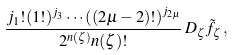<formula> <loc_0><loc_0><loc_500><loc_500>\frac { j _ { 1 } ! ( 1 ! ) ^ { j _ { 3 } } \cdots \left ( ( 2 \mu - 2 ) ! \right ) ^ { j _ { 2 \mu } } } { 2 ^ { n ( \zeta ) } n ( \zeta ) ! } \, D _ { \zeta } \tilde { f } _ { \zeta } \, ,</formula> 